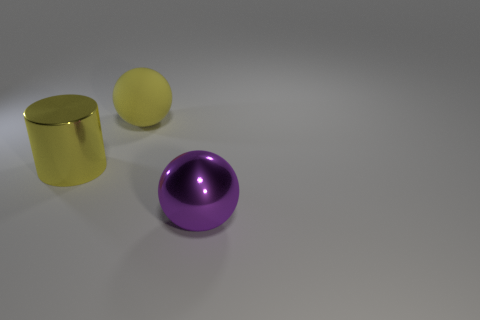How might the different colors of the objects affect our perception of them? The varying colors create a visual contrast, making each object distinct. Warm colors, like the yellow of the cylinder, often appear closer and more inviting, whereas cooler colors, like the purple of the hemisphere, might recede or appear more aloof. The color choices can influence emotional responses and depth perception in the image.  Do the materials look durable or fragile? The metallic finish on both the yellow cylinder and the purple hemisphere suggest durability and sturdiness, whereas the matte surface of the yellow ball gives off a softer, potentially less durable impression, perhaps indicative of a plastic or rubber material. 